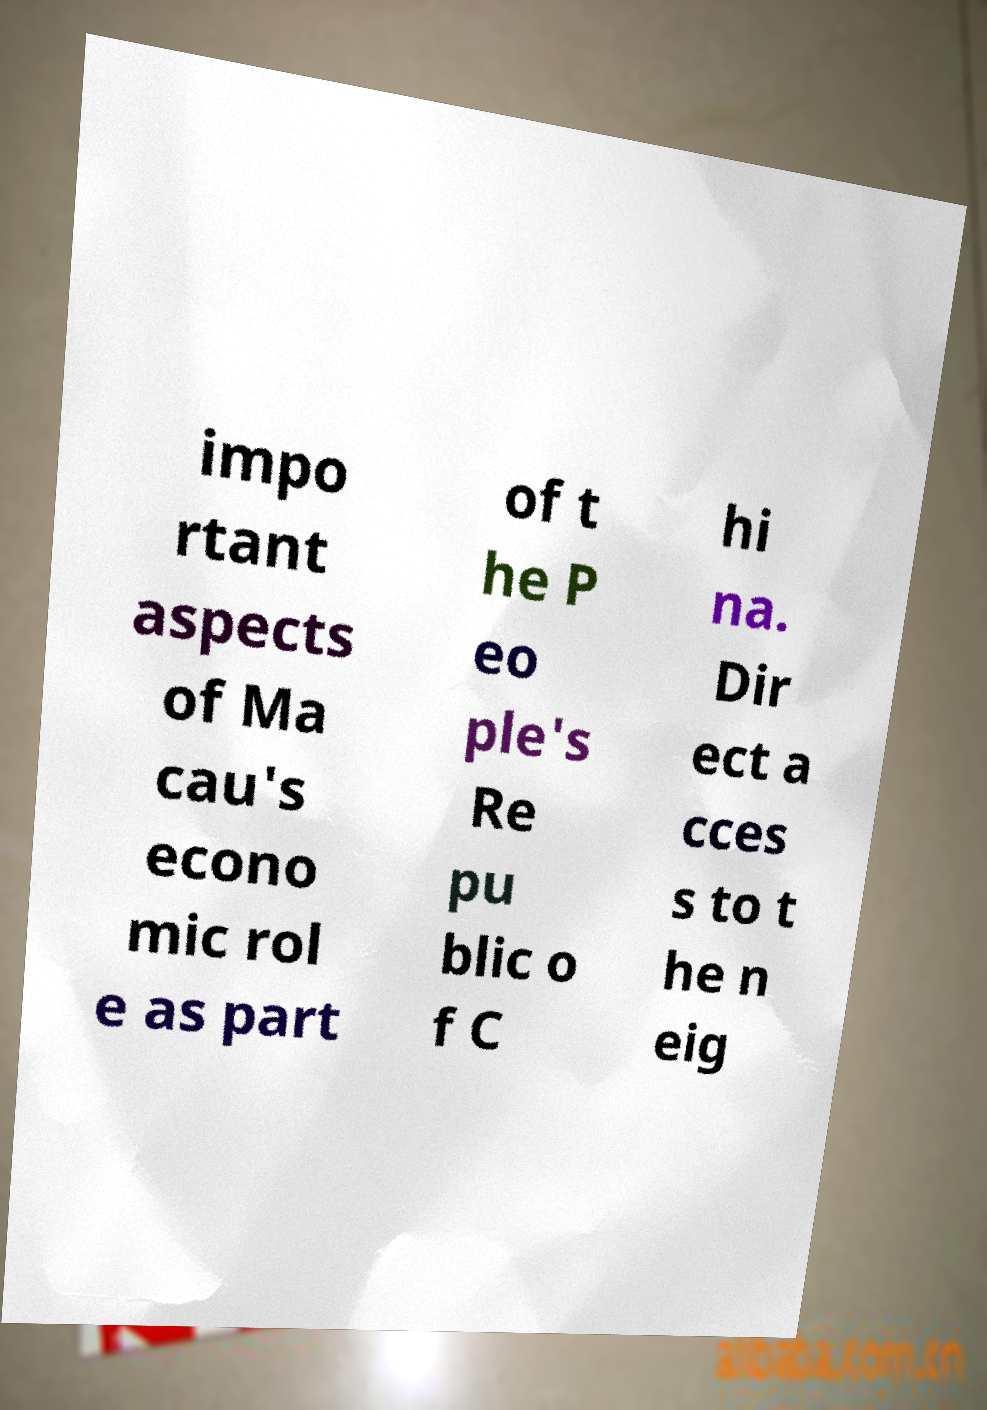Could you extract and type out the text from this image? impo rtant aspects of Ma cau's econo mic rol e as part of t he P eo ple's Re pu blic o f C hi na. Dir ect a cces s to t he n eig 